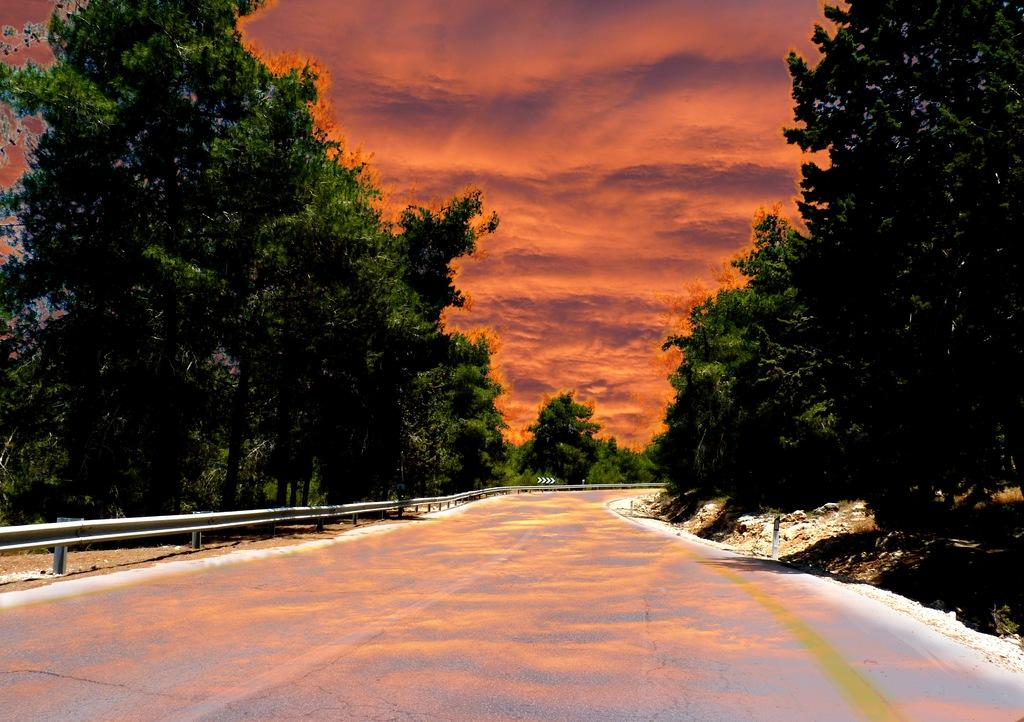What can be seen in the sky in the image? The sky with clouds is visible in the image. What type of vegetation is present in the image? There are trees in the image. What might be used to control traffic or restrict access in the image? There are barriers in the image. What type of surface is visible in the image? A road is present in the image. What is visible beneath the sky and trees in the image? The ground is visible in the image. What type of cherry is being served on the tray in the image? There is no tray or cherry present in the image. What type of feast is being prepared in the image? There is no feast or preparation visible in the image. 